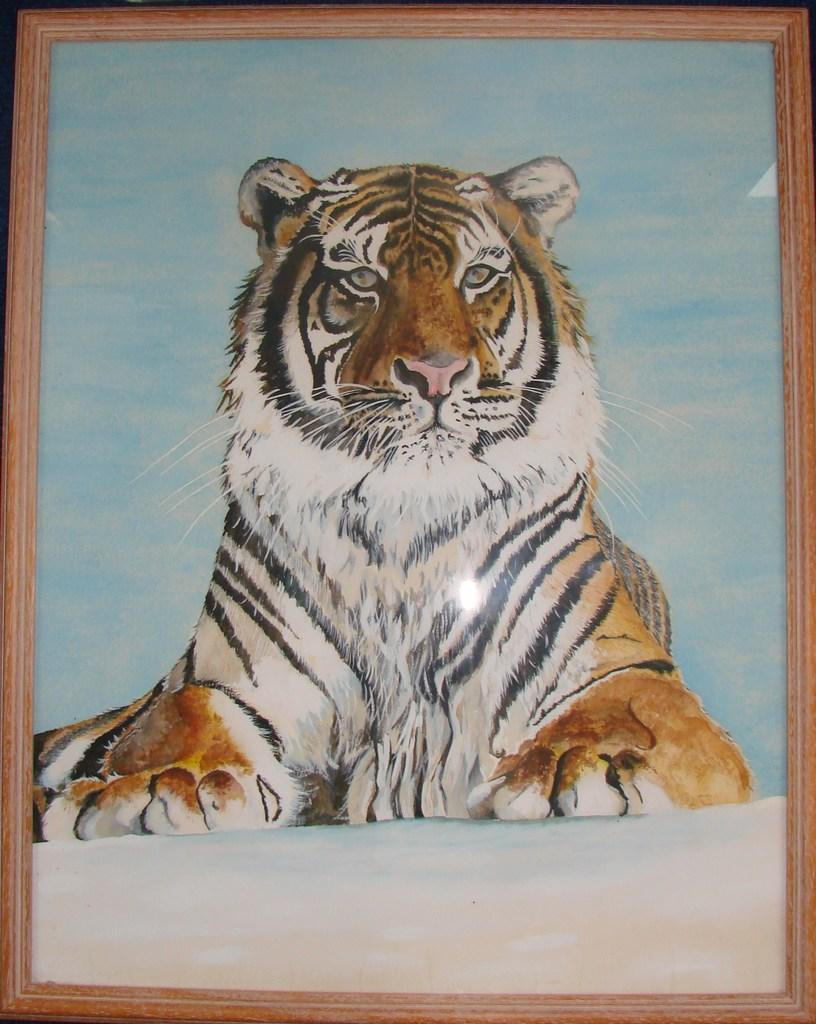What type of object is featured in the image? The image contains a painted photo frame. What is depicted within the photo frame? The photo frame depicts a tiger. What colors are used for the photo frame? The photo frame is white and brown in color. What is the condition of the tiger's quill in the image? There is no quill present in the image, as the depicted tiger is a painted image within the photo frame. 